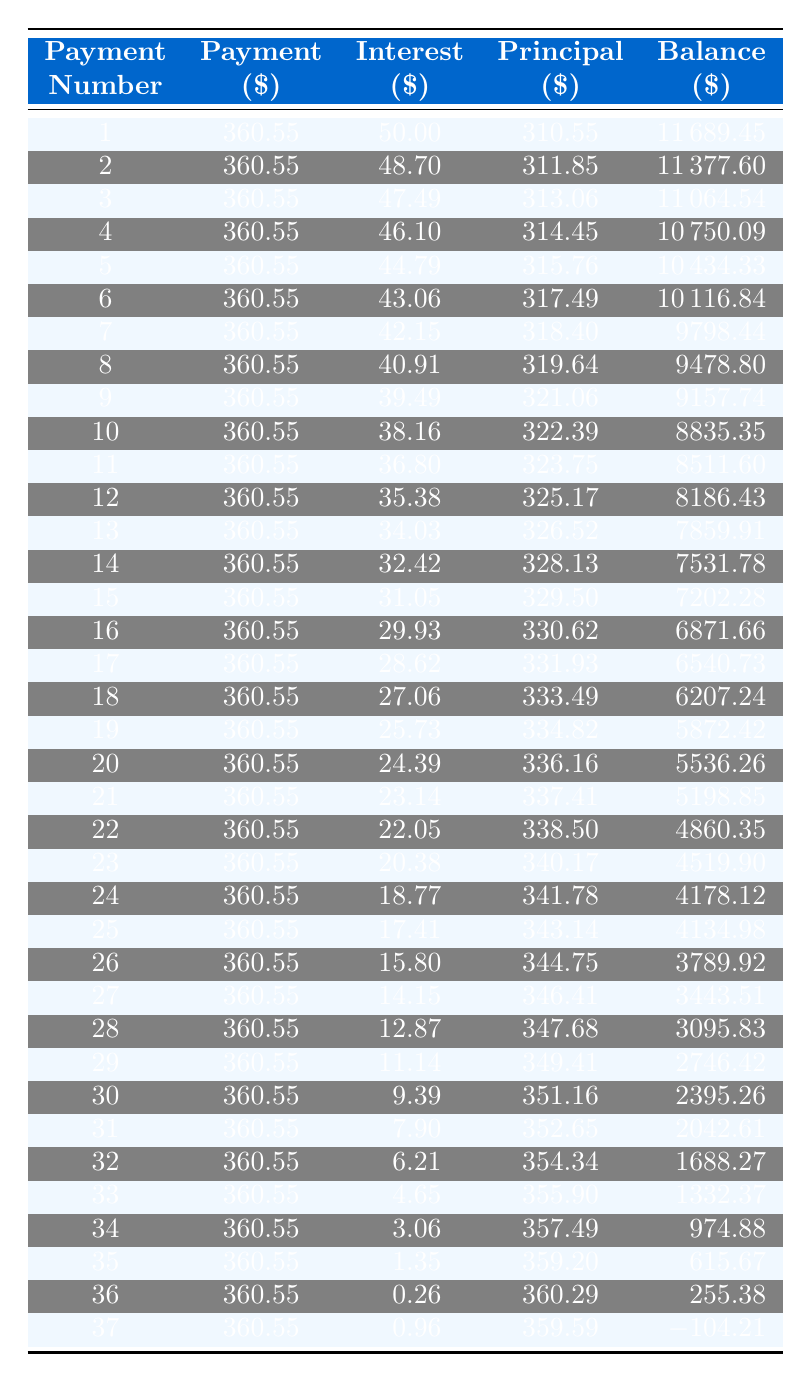What is the monthly payment amount? The monthly payment amount for the loan is listed directly in the funding details section of the table; it is $360.55.
Answer: 360.55 How much principal is paid off in the first payment? In the first payment row, the principal amount is stated as $310.55.
Answer: 310.55 What is the total interest paid after the first year (12 payments)? To find the total interest after the first year, we sum the interest amounts from the first 12 payment rows: 50.00 + 48.70 + 47.49 + 46.10 + 44.79 + 43.06 + 42.15 + 40.91 + 39.49 + 38.16 + 36.80 + 35.38 = 510.01.
Answer: 510.01 Is the interest paid in the last payment greater than the first payment? Looking at the interest amounts, the last payment has an interest of $0.96, and the first payment has an interest of $50.00. Since $0.96 is less than $50.00, the statement is false.
Answer: No What is the remaining balance after 24 payments? The balance after the 24th payment is listed in the table as $4,178.12.
Answer: 4,178.12 How much total principal has been paid off after the first 6 payments? The principal paid off in each of the first 6 payments is: 310.55 + 311.85 + 313.06 + 314.45 + 315.76 + 317.49 = 1,783.16.
Answer: 1,783.16 Is the interest amount decreasing with each payment? By analyzing the interest amounts over the payments, we see a consistent decrease, indicating that this statement is true.
Answer: Yes What is the average principal paid per month over the entire loan term? The total principal paid over the 36 payments is 12000 - 255.38 (final balance) = 11,744.62. The average is 11,744.62 / 36 ≈ 326.01.
Answer: 326.01 